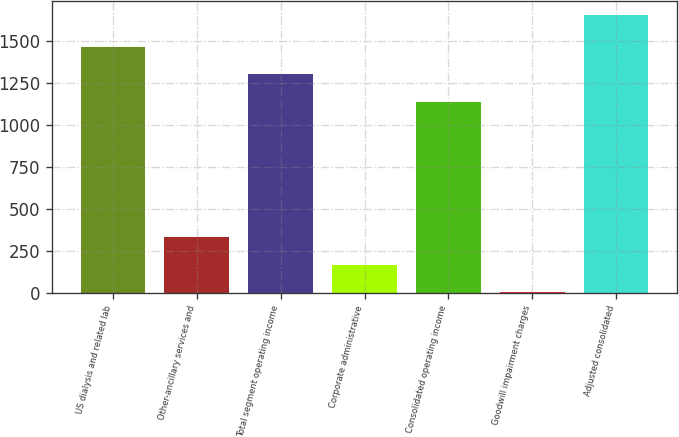<chart> <loc_0><loc_0><loc_500><loc_500><bar_chart><fcel>US dialysis and related lab<fcel>Other-ancillary services and<fcel>Total segment operating income<fcel>Corporate administrative<fcel>Consolidated operating income<fcel>Goodwill impairment charges<fcel>Adjusted consolidated<nl><fcel>1467.8<fcel>334.8<fcel>1302.4<fcel>169.4<fcel>1137<fcel>4<fcel>1658<nl></chart> 